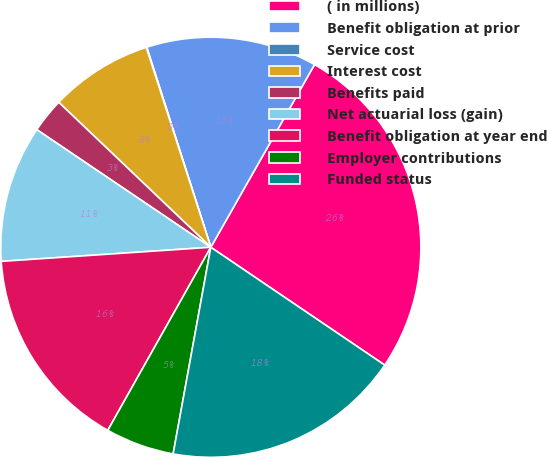Convert chart to OTSL. <chart><loc_0><loc_0><loc_500><loc_500><pie_chart><fcel>( in millions)<fcel>Benefit obligation at prior<fcel>Service cost<fcel>Interest cost<fcel>Benefits paid<fcel>Net actuarial loss (gain)<fcel>Benefit obligation at year end<fcel>Employer contributions<fcel>Funded status<nl><fcel>26.26%<fcel>13.15%<fcel>0.04%<fcel>7.91%<fcel>2.66%<fcel>10.53%<fcel>15.77%<fcel>5.29%<fcel>18.39%<nl></chart> 